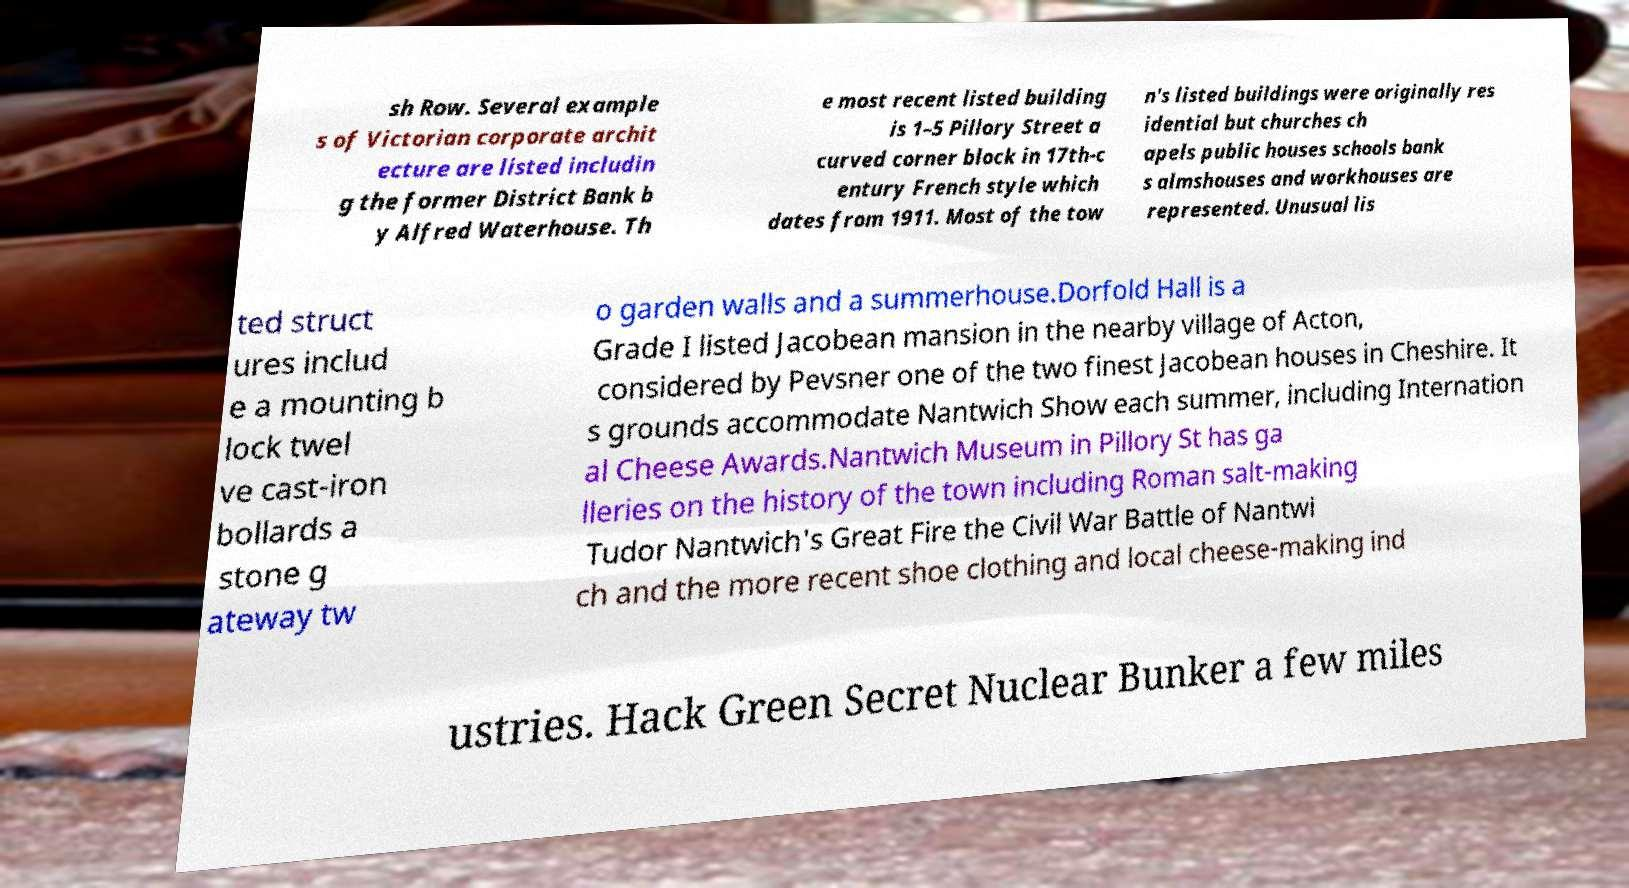What messages or text are displayed in this image? I need them in a readable, typed format. sh Row. Several example s of Victorian corporate archit ecture are listed includin g the former District Bank b y Alfred Waterhouse. Th e most recent listed building is 1–5 Pillory Street a curved corner block in 17th-c entury French style which dates from 1911. Most of the tow n's listed buildings were originally res idential but churches ch apels public houses schools bank s almshouses and workhouses are represented. Unusual lis ted struct ures includ e a mounting b lock twel ve cast-iron bollards a stone g ateway tw o garden walls and a summerhouse.Dorfold Hall is a Grade I listed Jacobean mansion in the nearby village of Acton, considered by Pevsner one of the two finest Jacobean houses in Cheshire. It s grounds accommodate Nantwich Show each summer, including Internation al Cheese Awards.Nantwich Museum in Pillory St has ga lleries on the history of the town including Roman salt-making Tudor Nantwich's Great Fire the Civil War Battle of Nantwi ch and the more recent shoe clothing and local cheese-making ind ustries. Hack Green Secret Nuclear Bunker a few miles 